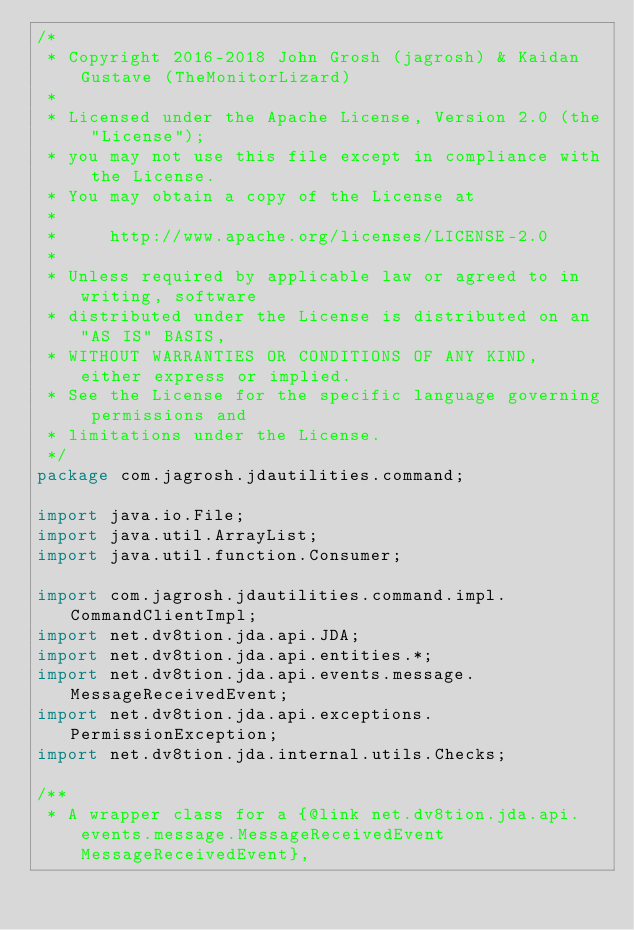<code> <loc_0><loc_0><loc_500><loc_500><_Java_>/*
 * Copyright 2016-2018 John Grosh (jagrosh) & Kaidan Gustave (TheMonitorLizard)
 *
 * Licensed under the Apache License, Version 2.0 (the "License");
 * you may not use this file except in compliance with the License.
 * You may obtain a copy of the License at
 *
 *     http://www.apache.org/licenses/LICENSE-2.0
 *
 * Unless required by applicable law or agreed to in writing, software
 * distributed under the License is distributed on an "AS IS" BASIS,
 * WITHOUT WARRANTIES OR CONDITIONS OF ANY KIND, either express or implied.
 * See the License for the specific language governing permissions and
 * limitations under the License.
 */
package com.jagrosh.jdautilities.command;

import java.io.File;
import java.util.ArrayList;
import java.util.function.Consumer;

import com.jagrosh.jdautilities.command.impl.CommandClientImpl;
import net.dv8tion.jda.api.JDA;
import net.dv8tion.jda.api.entities.*;
import net.dv8tion.jda.api.events.message.MessageReceivedEvent;
import net.dv8tion.jda.api.exceptions.PermissionException;
import net.dv8tion.jda.internal.utils.Checks;

/**
 * A wrapper class for a {@link net.dv8tion.jda.api.events.message.MessageReceivedEvent MessageReceivedEvent},</code> 